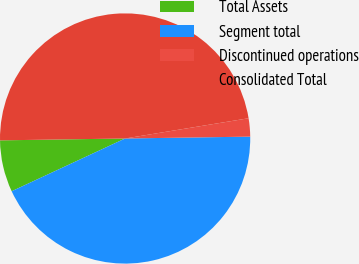<chart> <loc_0><loc_0><loc_500><loc_500><pie_chart><fcel>Total Assets<fcel>Segment total<fcel>Discontinued operations<fcel>Consolidated Total<nl><fcel>6.69%<fcel>43.31%<fcel>2.35%<fcel>47.65%<nl></chart> 